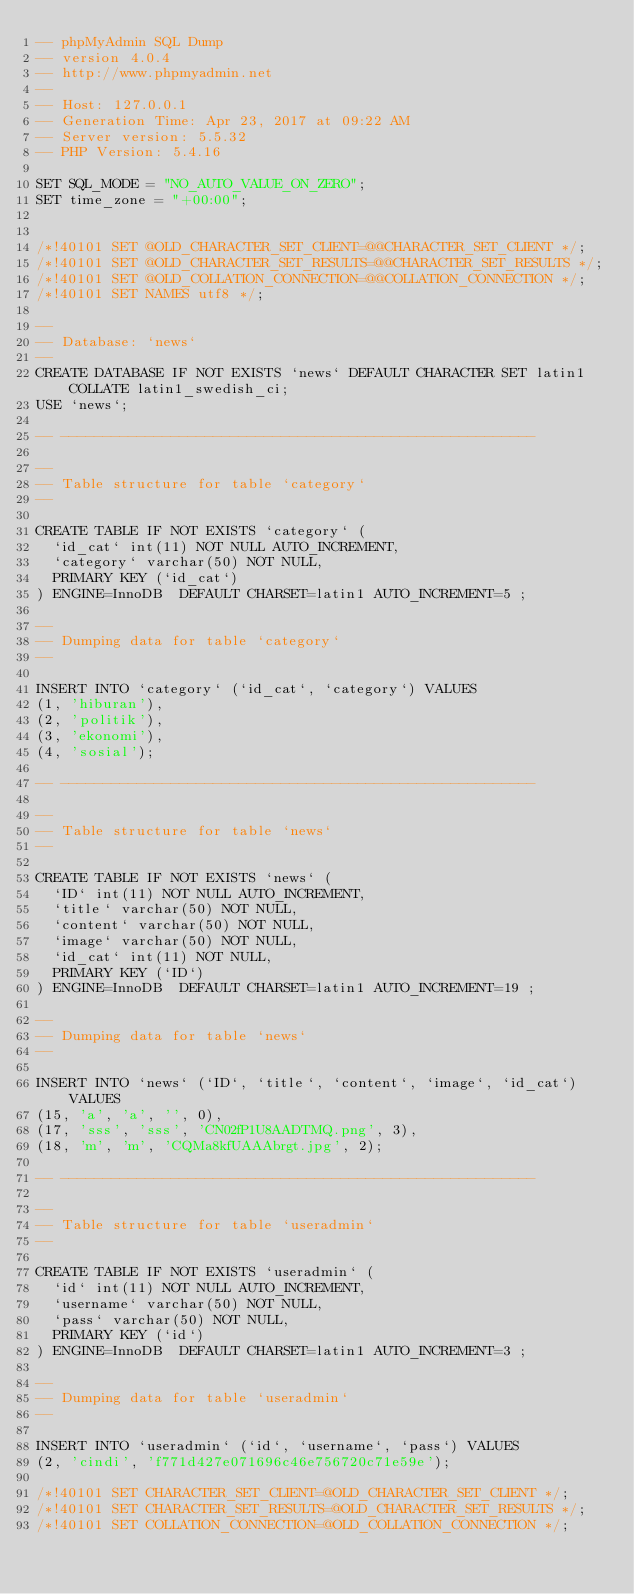<code> <loc_0><loc_0><loc_500><loc_500><_SQL_>-- phpMyAdmin SQL Dump
-- version 4.0.4
-- http://www.phpmyadmin.net
--
-- Host: 127.0.0.1
-- Generation Time: Apr 23, 2017 at 09:22 AM
-- Server version: 5.5.32
-- PHP Version: 5.4.16

SET SQL_MODE = "NO_AUTO_VALUE_ON_ZERO";
SET time_zone = "+00:00";


/*!40101 SET @OLD_CHARACTER_SET_CLIENT=@@CHARACTER_SET_CLIENT */;
/*!40101 SET @OLD_CHARACTER_SET_RESULTS=@@CHARACTER_SET_RESULTS */;
/*!40101 SET @OLD_COLLATION_CONNECTION=@@COLLATION_CONNECTION */;
/*!40101 SET NAMES utf8 */;

--
-- Database: `news`
--
CREATE DATABASE IF NOT EXISTS `news` DEFAULT CHARACTER SET latin1 COLLATE latin1_swedish_ci;
USE `news`;

-- --------------------------------------------------------

--
-- Table structure for table `category`
--

CREATE TABLE IF NOT EXISTS `category` (
  `id_cat` int(11) NOT NULL AUTO_INCREMENT,
  `category` varchar(50) NOT NULL,
  PRIMARY KEY (`id_cat`)
) ENGINE=InnoDB  DEFAULT CHARSET=latin1 AUTO_INCREMENT=5 ;

--
-- Dumping data for table `category`
--

INSERT INTO `category` (`id_cat`, `category`) VALUES
(1, 'hiburan'),
(2, 'politik'),
(3, 'ekonomi'),
(4, 'sosial');

-- --------------------------------------------------------

--
-- Table structure for table `news`
--

CREATE TABLE IF NOT EXISTS `news` (
  `ID` int(11) NOT NULL AUTO_INCREMENT,
  `title` varchar(50) NOT NULL,
  `content` varchar(50) NOT NULL,
  `image` varchar(50) NOT NULL,
  `id_cat` int(11) NOT NULL,
  PRIMARY KEY (`ID`)
) ENGINE=InnoDB  DEFAULT CHARSET=latin1 AUTO_INCREMENT=19 ;

--
-- Dumping data for table `news`
--

INSERT INTO `news` (`ID`, `title`, `content`, `image`, `id_cat`) VALUES
(15, 'a', 'a', '', 0),
(17, 'sss', 'sss', 'CN02fP1U8AADTMQ.png', 3),
(18, 'm', 'm', 'CQMa8kfUAAAbrgt.jpg', 2);

-- --------------------------------------------------------

--
-- Table structure for table `useradmin`
--

CREATE TABLE IF NOT EXISTS `useradmin` (
  `id` int(11) NOT NULL AUTO_INCREMENT,
  `username` varchar(50) NOT NULL,
  `pass` varchar(50) NOT NULL,
  PRIMARY KEY (`id`)
) ENGINE=InnoDB  DEFAULT CHARSET=latin1 AUTO_INCREMENT=3 ;

--
-- Dumping data for table `useradmin`
--

INSERT INTO `useradmin` (`id`, `username`, `pass`) VALUES
(2, 'cindi', 'f771d427e071696c46e756720c71e59e');

/*!40101 SET CHARACTER_SET_CLIENT=@OLD_CHARACTER_SET_CLIENT */;
/*!40101 SET CHARACTER_SET_RESULTS=@OLD_CHARACTER_SET_RESULTS */;
/*!40101 SET COLLATION_CONNECTION=@OLD_COLLATION_CONNECTION */;
</code> 